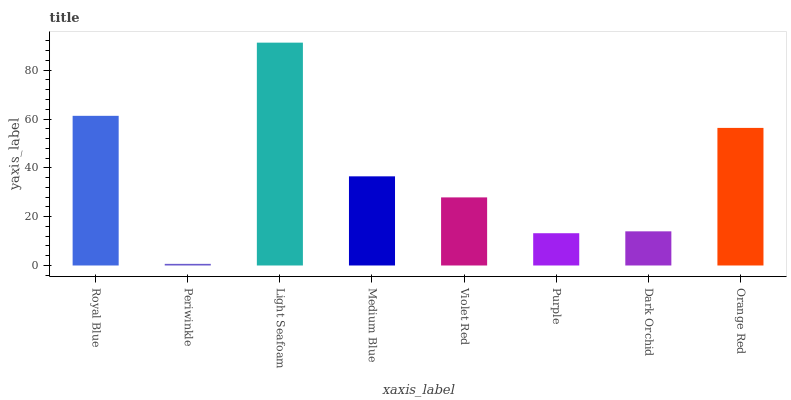Is Periwinkle the minimum?
Answer yes or no. Yes. Is Light Seafoam the maximum?
Answer yes or no. Yes. Is Light Seafoam the minimum?
Answer yes or no. No. Is Periwinkle the maximum?
Answer yes or no. No. Is Light Seafoam greater than Periwinkle?
Answer yes or no. Yes. Is Periwinkle less than Light Seafoam?
Answer yes or no. Yes. Is Periwinkle greater than Light Seafoam?
Answer yes or no. No. Is Light Seafoam less than Periwinkle?
Answer yes or no. No. Is Medium Blue the high median?
Answer yes or no. Yes. Is Violet Red the low median?
Answer yes or no. Yes. Is Purple the high median?
Answer yes or no. No. Is Royal Blue the low median?
Answer yes or no. No. 